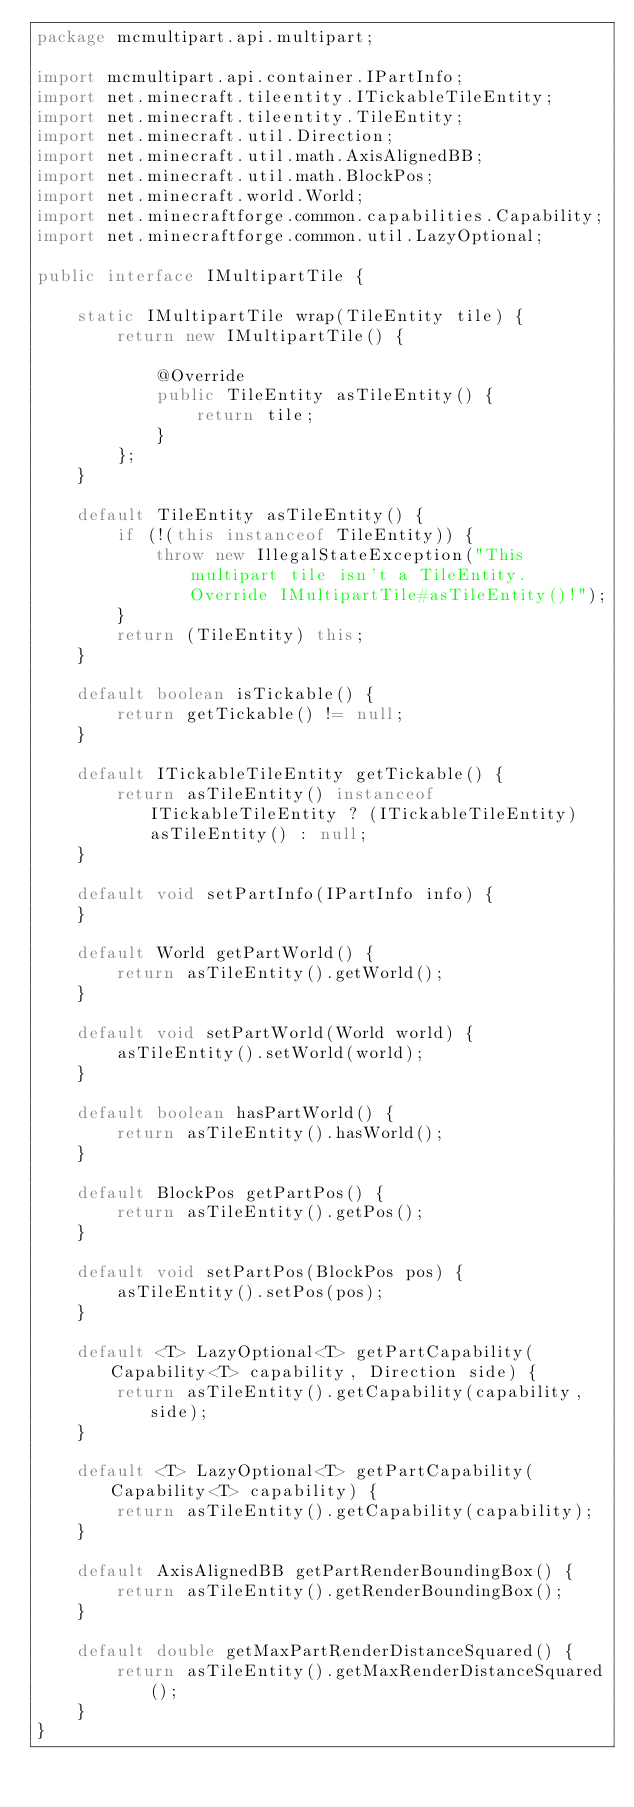<code> <loc_0><loc_0><loc_500><loc_500><_Java_>package mcmultipart.api.multipart;

import mcmultipart.api.container.IPartInfo;
import net.minecraft.tileentity.ITickableTileEntity;
import net.minecraft.tileentity.TileEntity;
import net.minecraft.util.Direction;
import net.minecraft.util.math.AxisAlignedBB;
import net.minecraft.util.math.BlockPos;
import net.minecraft.world.World;
import net.minecraftforge.common.capabilities.Capability;
import net.minecraftforge.common.util.LazyOptional;

public interface IMultipartTile {

    static IMultipartTile wrap(TileEntity tile) {
        return new IMultipartTile() {

            @Override
            public TileEntity asTileEntity() {
                return tile;
            }
        };
    }

    default TileEntity asTileEntity() {
        if (!(this instanceof TileEntity)) {
            throw new IllegalStateException("This multipart tile isn't a TileEntity. Override IMultipartTile#asTileEntity()!");
        }
        return (TileEntity) this;
    }

    default boolean isTickable() {
        return getTickable() != null;
    }

    default ITickableTileEntity getTickable() {
        return asTileEntity() instanceof ITickableTileEntity ? (ITickableTileEntity) asTileEntity() : null;
    }

    default void setPartInfo(IPartInfo info) {
    }

    default World getPartWorld() {
        return asTileEntity().getWorld();
    }

    default void setPartWorld(World world) {
        asTileEntity().setWorld(world);
    }

    default boolean hasPartWorld() {
        return asTileEntity().hasWorld();
    }

    default BlockPos getPartPos() {
        return asTileEntity().getPos();
    }

    default void setPartPos(BlockPos pos) {
        asTileEntity().setPos(pos);
    }

    default <T> LazyOptional<T> getPartCapability(Capability<T> capability, Direction side) {
        return asTileEntity().getCapability(capability, side);
    }

    default <T> LazyOptional<T> getPartCapability(Capability<T> capability) {
        return asTileEntity().getCapability(capability);
    }

    default AxisAlignedBB getPartRenderBoundingBox() {
        return asTileEntity().getRenderBoundingBox();
    }

    default double getMaxPartRenderDistanceSquared() {
        return asTileEntity().getMaxRenderDistanceSquared();
    }
}</code> 